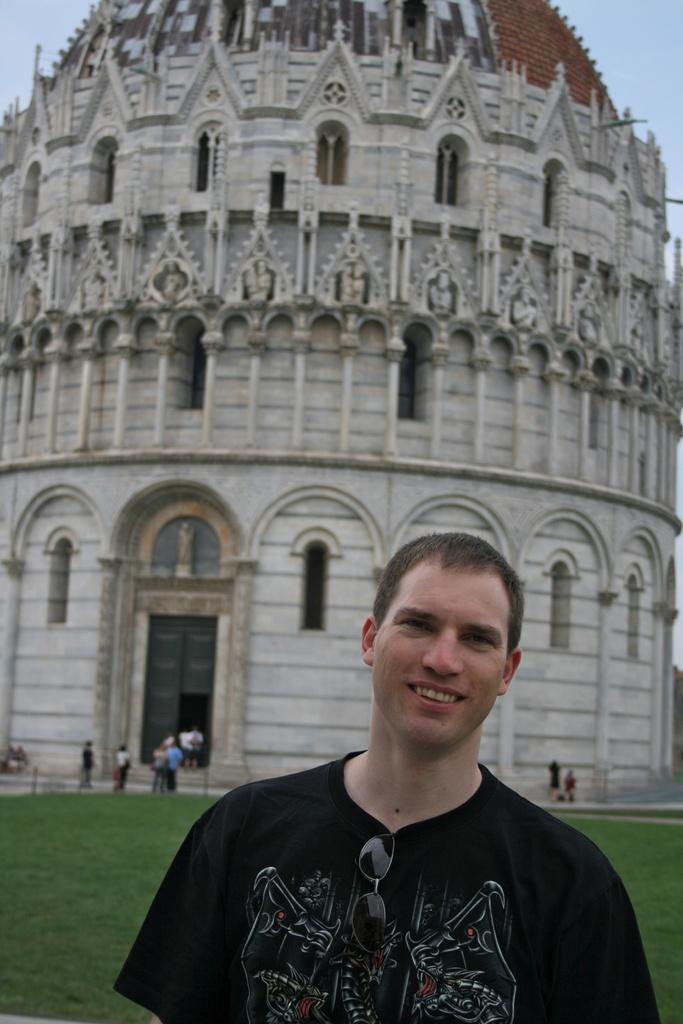Please provide a concise description of this image. In this image we can see a man smiling. He is wearing a black shirt. In the background there is a tower and we can see people. At the top there is sky. 